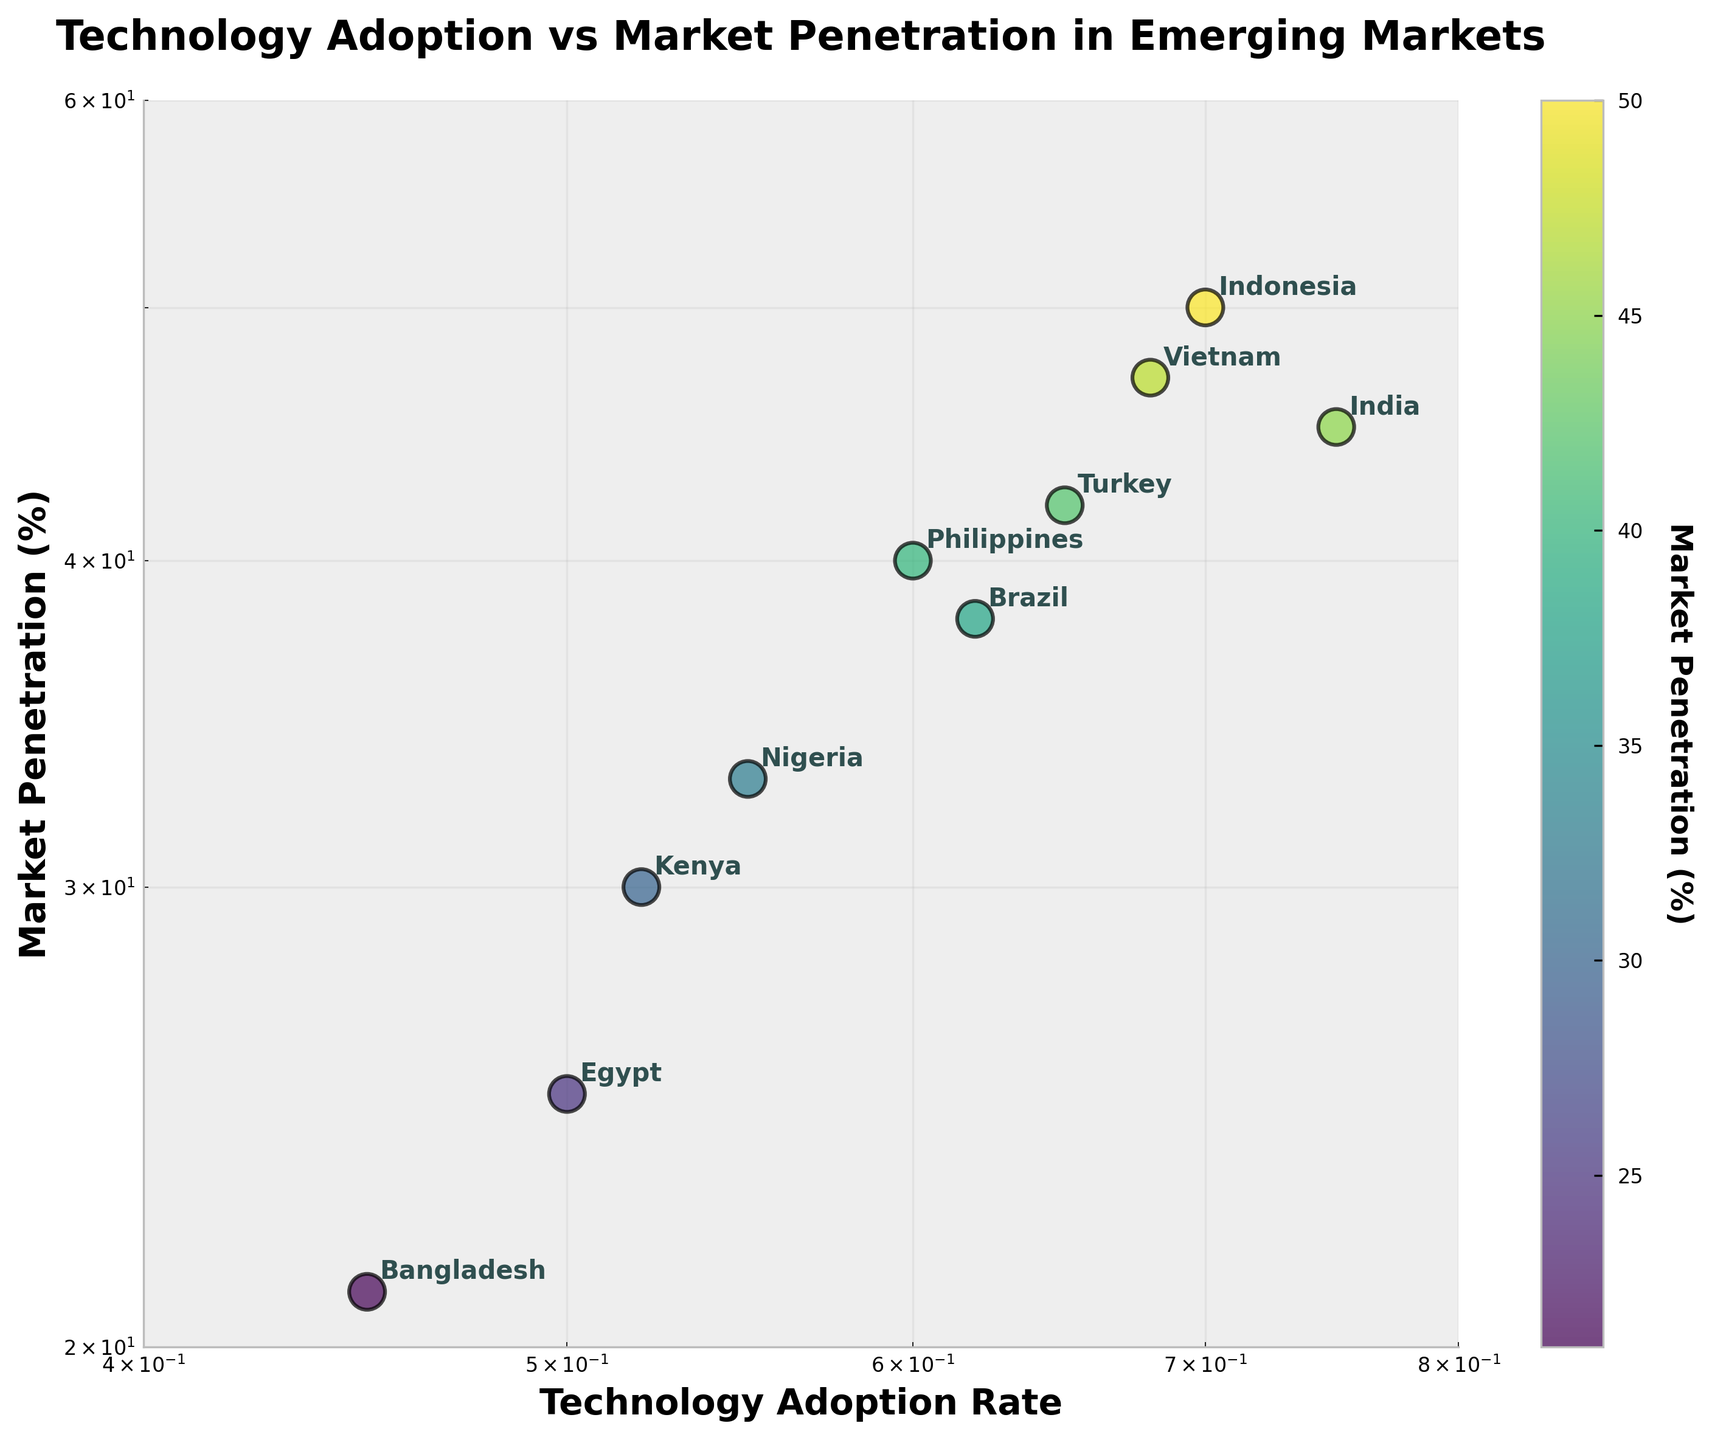What's the title of the plot? The title is located at the top of the plot and it is 'Technology Adoption vs Market Penetration in Emerging Markets'.
Answer: Technology Adoption vs Market Penetration in Emerging Markets How many countries are represented in the plot? Count the number of unique data points each labeled by country names.
Answer: 10 Which country has the highest market penetration? Identify the data point with the highest y-value, which corresponds to Market Penetration. The annotated label next to it will reveal the country name.
Answer: Indonesia What is the market penetration rate for Nigeria? Locate the data point labeled 'Nigeria' and note the y-axis value corresponding to it.
Answer: 33% Which countries have a technology adoption rate greater than 0.6? Identify the data points to the right of the 0.6 value on the x-axis and list their annotated country names.
Answer: India, Brazil, Indonesia, Vietnam, Philippines, Turkey Is there a country with a technology adoption rate less than 0.5? Look for data points to the left of the 0.5 value on the x-axis and note the annotated country name (or names).
Answer: Bangladesh What is the difference in market penetration between India and Bangladesh? Locate the y-axis values for India (45) and Bangladesh (21) and subtract the smaller from the larger.
Answer: 24% How does the market penetration of Turkey compare to that of Brazil? Compare the y-axis values for Turkey (42) and Brazil (38) to determine which is greater.
Answer: Turkey Which country exhibits both a high technology adoption rate and high market penetration? Look for the upper-rightmost data points, which indicate both high x and y values and note the corresponding country name.
Answer: Indonesia Which country shows the lowest technology adoption rate, and what is its market penetration? Locate the data point furthest to the left on the x-axis, identify the country and check the corresponding y-axis value for market penetration.
Answer: Bangladesh, 21% 